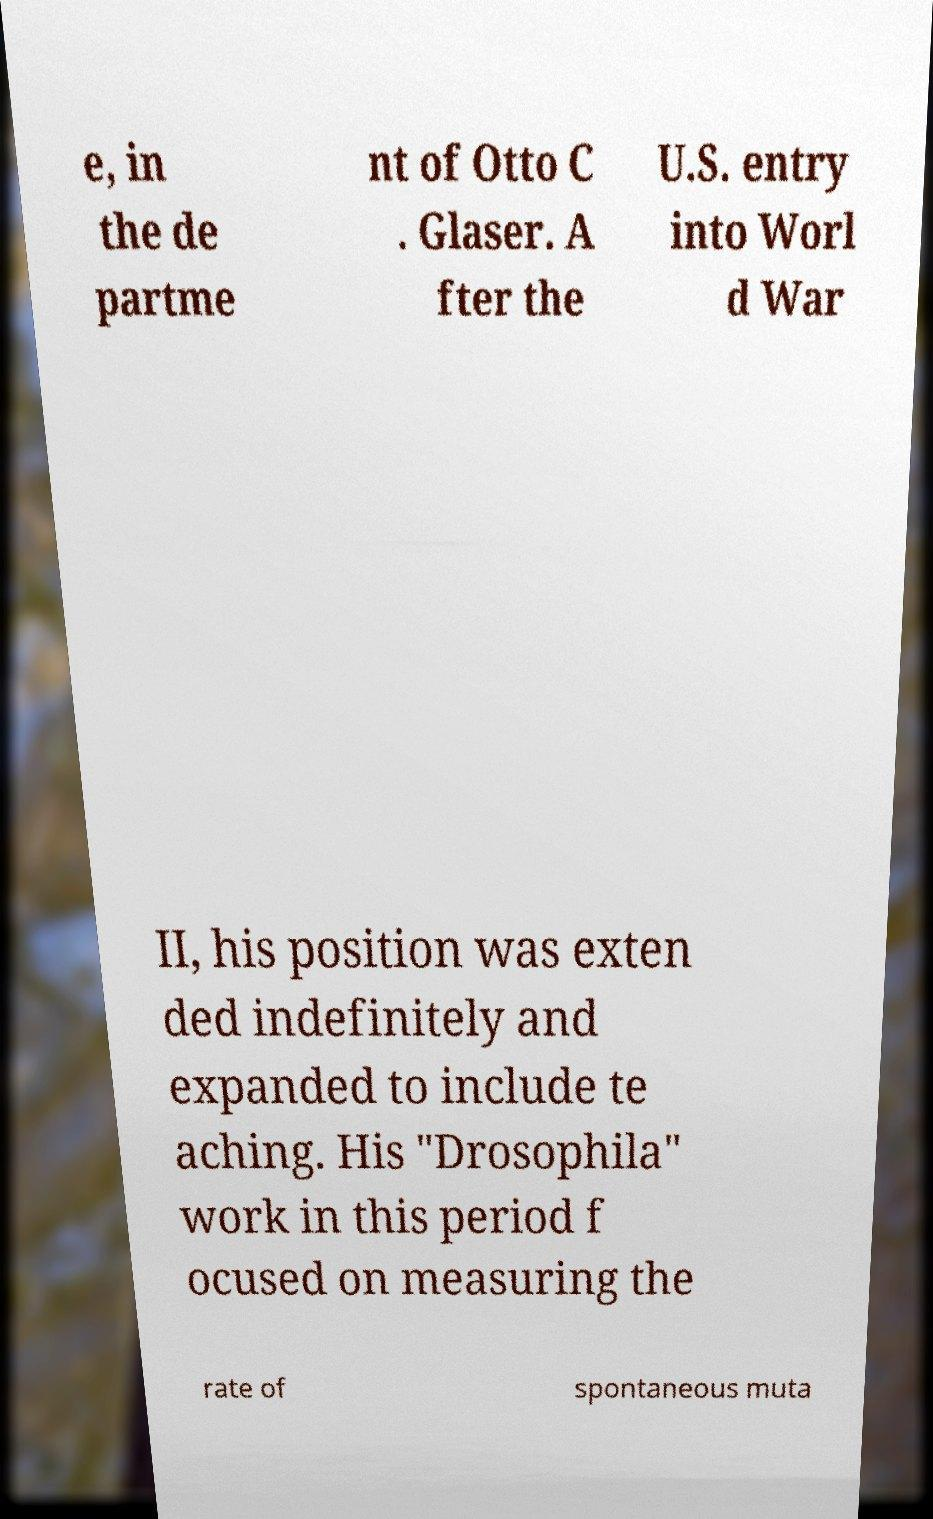Could you extract and type out the text from this image? e, in the de partme nt of Otto C . Glaser. A fter the U.S. entry into Worl d War II, his position was exten ded indefinitely and expanded to include te aching. His "Drosophila" work in this period f ocused on measuring the rate of spontaneous muta 